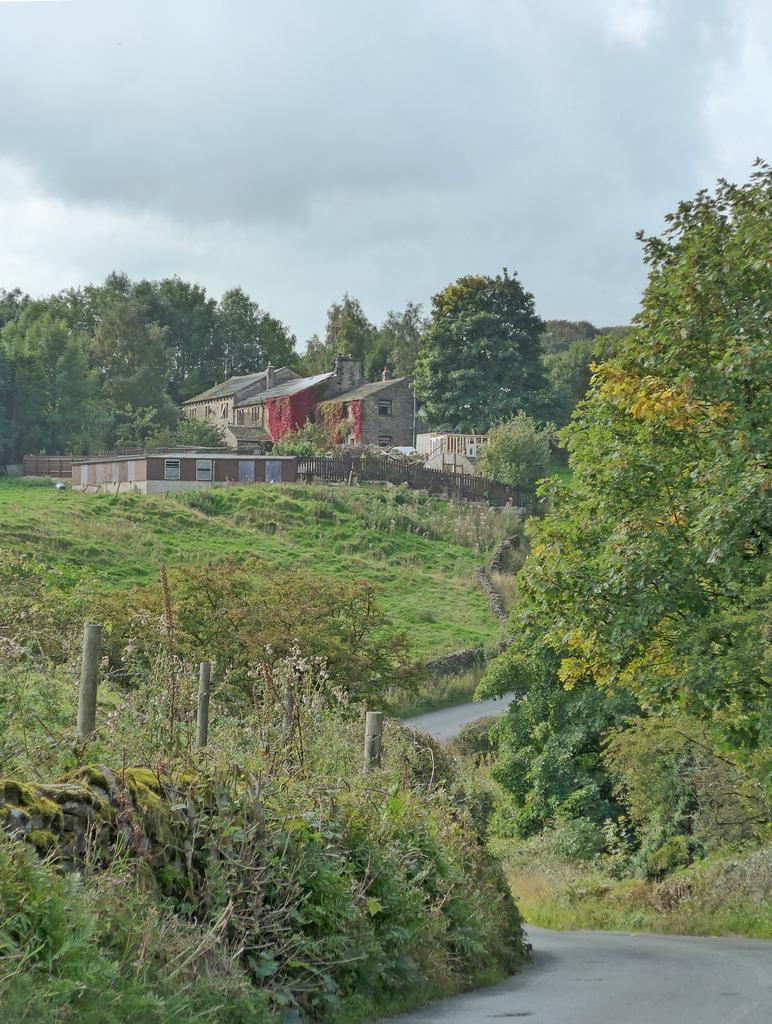Can you describe this image briefly? It is a beautiful scenery there is a lot of grass on the either side of the road and on the left side there are two houses and around the houses there are plenty of trees. 